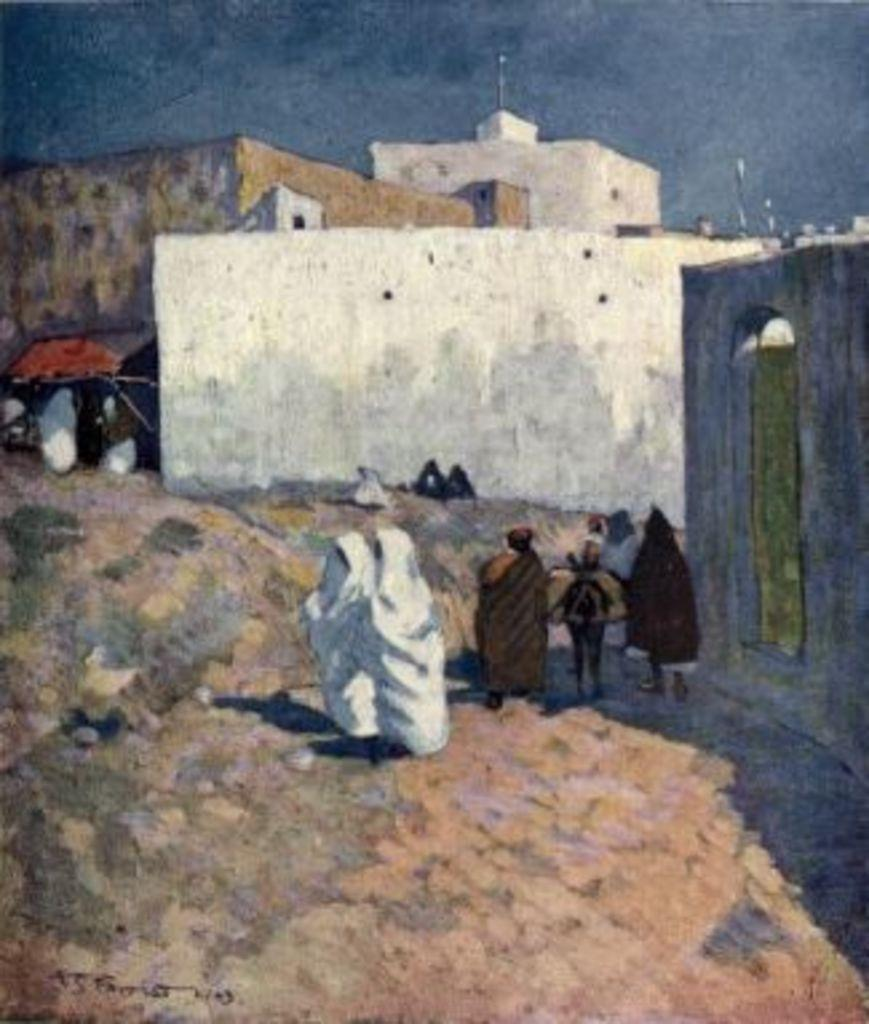What is happening on the ground in the image? There are people on the ground in the image. What can be seen in the distance behind the people? There are buildings in the background of the image. What is visible above the buildings in the image? The sky is visible in the background of the image. What song is being sung by the rabbit in the image? There is no rabbit present in the image, and therefore no song being sung. 